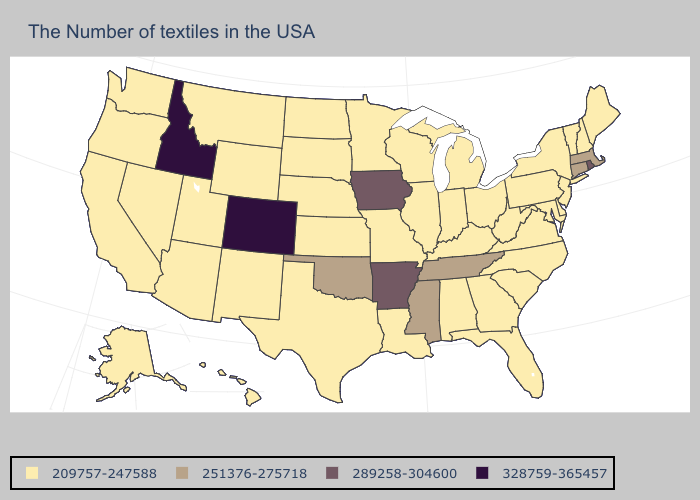What is the highest value in states that border Kansas?
Keep it brief. 328759-365457. Which states have the highest value in the USA?
Keep it brief. Colorado, Idaho. Which states have the lowest value in the USA?
Keep it brief. Maine, New Hampshire, Vermont, New York, New Jersey, Delaware, Maryland, Pennsylvania, Virginia, North Carolina, South Carolina, West Virginia, Ohio, Florida, Georgia, Michigan, Kentucky, Indiana, Alabama, Wisconsin, Illinois, Louisiana, Missouri, Minnesota, Kansas, Nebraska, Texas, South Dakota, North Dakota, Wyoming, New Mexico, Utah, Montana, Arizona, Nevada, California, Washington, Oregon, Alaska, Hawaii. Which states have the lowest value in the USA?
Short answer required. Maine, New Hampshire, Vermont, New York, New Jersey, Delaware, Maryland, Pennsylvania, Virginia, North Carolina, South Carolina, West Virginia, Ohio, Florida, Georgia, Michigan, Kentucky, Indiana, Alabama, Wisconsin, Illinois, Louisiana, Missouri, Minnesota, Kansas, Nebraska, Texas, South Dakota, North Dakota, Wyoming, New Mexico, Utah, Montana, Arizona, Nevada, California, Washington, Oregon, Alaska, Hawaii. Does Ohio have a lower value than Iowa?
Keep it brief. Yes. Name the states that have a value in the range 251376-275718?
Give a very brief answer. Massachusetts, Connecticut, Tennessee, Mississippi, Oklahoma. Is the legend a continuous bar?
Give a very brief answer. No. What is the lowest value in the USA?
Keep it brief. 209757-247588. Which states hav the highest value in the MidWest?
Quick response, please. Iowa. Does Maryland have a higher value than Vermont?
Write a very short answer. No. What is the value of New Mexico?
Give a very brief answer. 209757-247588. How many symbols are there in the legend?
Short answer required. 4. Does Illinois have the same value as California?
Concise answer only. Yes. What is the value of Maine?
Short answer required. 209757-247588. 